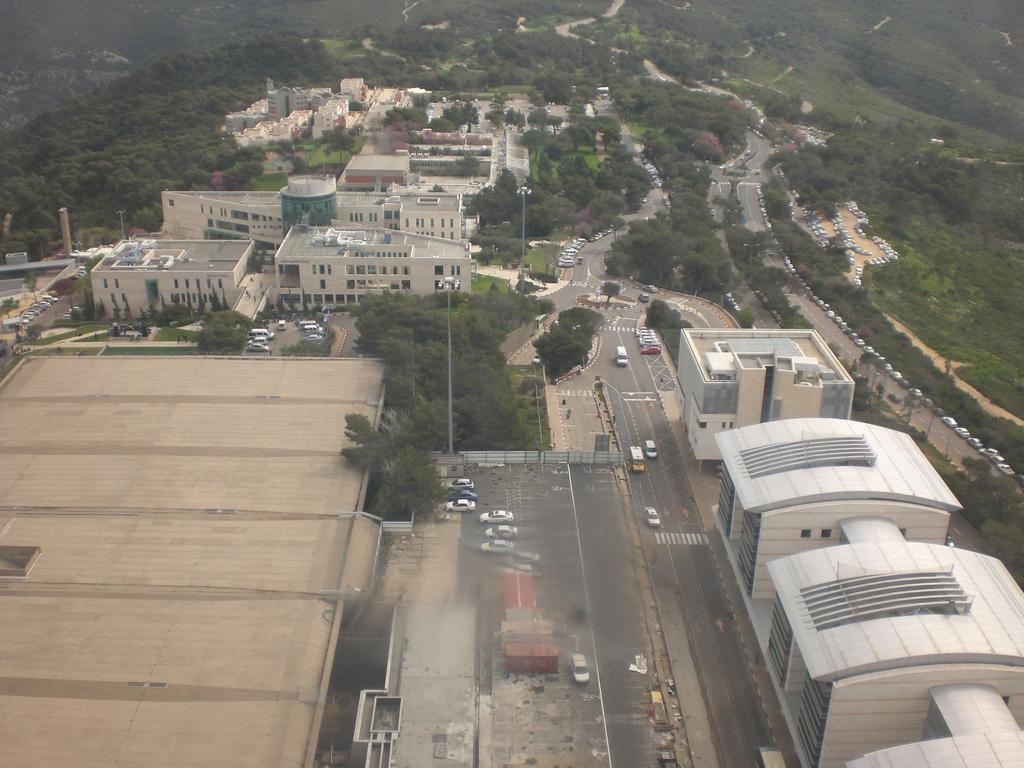Could you give a brief overview of what you see in this image? In the center of the image there is a road and we can see cars and buses on the road. There are trees and buildings. We can see poles. In the background there are hills. 